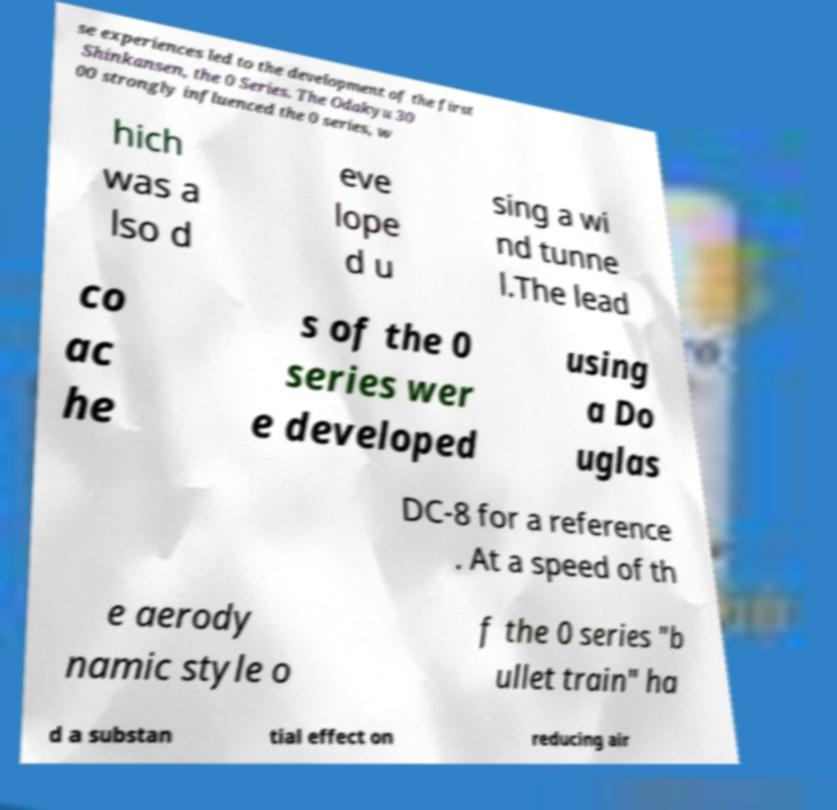For documentation purposes, I need the text within this image transcribed. Could you provide that? se experiences led to the development of the first Shinkansen, the 0 Series. The Odakyu 30 00 strongly influenced the 0 series, w hich was a lso d eve lope d u sing a wi nd tunne l.The lead co ac he s of the 0 series wer e developed using a Do uglas DC-8 for a reference . At a speed of th e aerody namic style o f the 0 series "b ullet train" ha d a substan tial effect on reducing air 